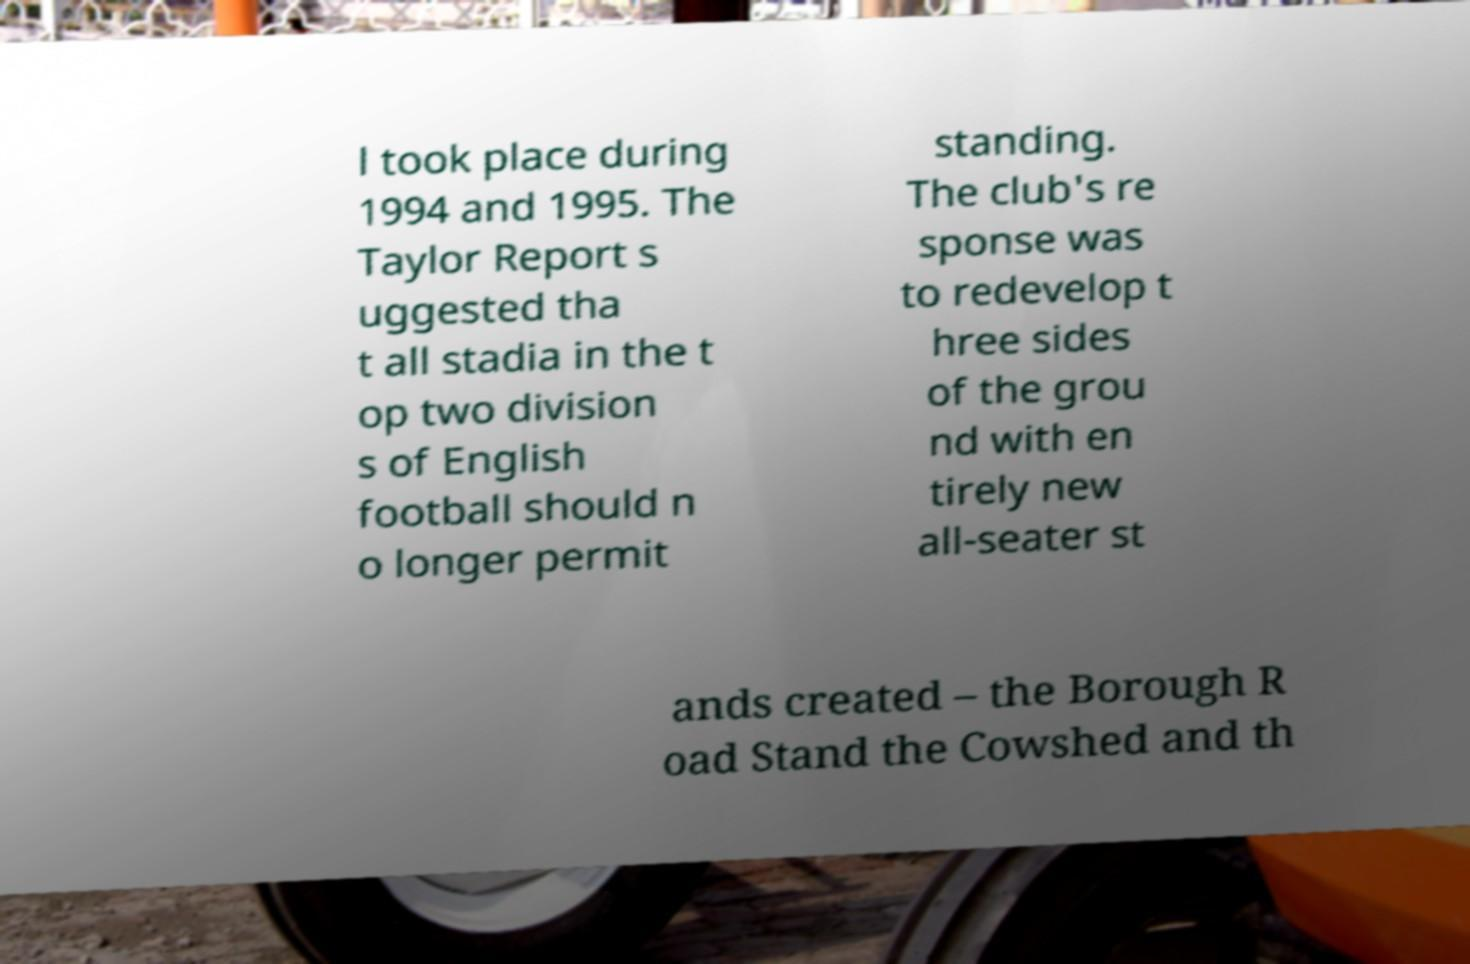Please identify and transcribe the text found in this image. l took place during 1994 and 1995. The Taylor Report s uggested tha t all stadia in the t op two division s of English football should n o longer permit standing. The club's re sponse was to redevelop t hree sides of the grou nd with en tirely new all-seater st ands created – the Borough R oad Stand the Cowshed and th 